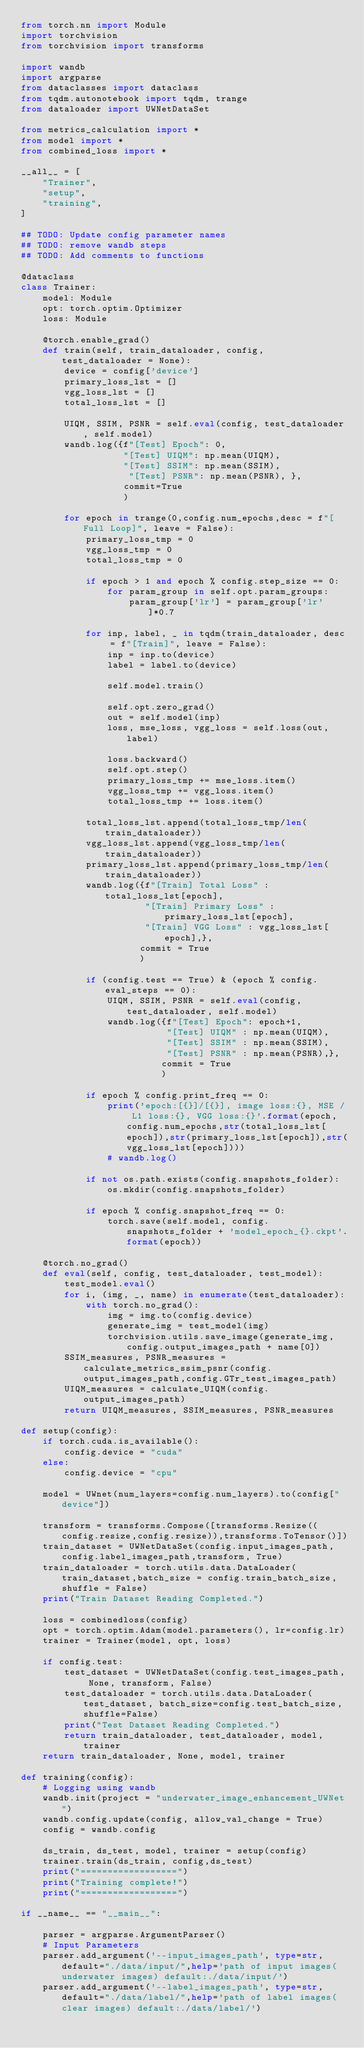<code> <loc_0><loc_0><loc_500><loc_500><_Python_>from torch.nn import Module
import torchvision
from torchvision import transforms

import wandb
import argparse
from dataclasses import dataclass
from tqdm.autonotebook import tqdm, trange
from dataloader import UWNetDataSet

from metrics_calculation import *
from model import *
from combined_loss import *

__all__ = [
    "Trainer",
    "setup",
    "training",
]

## TODO: Update config parameter names
## TODO: remove wandb steps
## TODO: Add comments to functions

@dataclass
class Trainer:
    model: Module
    opt: torch.optim.Optimizer
    loss: Module

    @torch.enable_grad()
    def train(self, train_dataloader, config, test_dataloader = None):
        device = config['device']
        primary_loss_lst = []
        vgg_loss_lst = []
        total_loss_lst = []

        UIQM, SSIM, PSNR = self.eval(config, test_dataloader, self.model)
        wandb.log({f"[Test] Epoch": 0,
                   "[Test] UIQM": np.mean(UIQM),
                   "[Test] SSIM": np.mean(SSIM),
                    "[Test] PSNR": np.mean(PSNR), },
                   commit=True
                   )

        for epoch in trange(0,config.num_epochs,desc = f"[Full Loop]", leave = False):
            primary_loss_tmp = 0
            vgg_loss_tmp = 0
            total_loss_tmp = 0

            if epoch > 1 and epoch % config.step_size == 0:
                for param_group in self.opt.param_groups:
                    param_group['lr'] = param_group['lr']*0.7

            for inp, label, _ in tqdm(train_dataloader, desc = f"[Train]", leave = False):
                inp = inp.to(device)
                label = label.to(device)

                self.model.train()

                self.opt.zero_grad()
                out = self.model(inp)
                loss, mse_loss, vgg_loss = self.loss(out, label)

                loss.backward()
                self.opt.step()
                primary_loss_tmp += mse_loss.item()
                vgg_loss_tmp += vgg_loss.item()
                total_loss_tmp += loss.item()

            total_loss_lst.append(total_loss_tmp/len(train_dataloader))
            vgg_loss_lst.append(vgg_loss_tmp/len(train_dataloader))
            primary_loss_lst.append(primary_loss_tmp/len(train_dataloader))
            wandb.log({f"[Train] Total Loss" : total_loss_lst[epoch],
                       "[Train] Primary Loss" : primary_loss_lst[epoch],
                       "[Train] VGG Loss" : vgg_loss_lst[epoch],},
                      commit = True
                      )

            if (config.test == True) & (epoch % config.eval_steps == 0):
                UIQM, SSIM, PSNR = self.eval(config, test_dataloader, self.model)
                wandb.log({f"[Test] Epoch": epoch+1,
                           "[Test] UIQM" : np.mean(UIQM),
                           "[Test] SSIM" : np.mean(SSIM),
                           "[Test] PSNR" : np.mean(PSNR),},
                          commit = True
                          )

            if epoch % config.print_freq == 0:
                print('epoch:[{}]/[{}], image loss:{}, MSE / L1 loss:{}, VGG loss:{}'.format(epoch,config.num_epochs,str(total_loss_lst[epoch]),str(primary_loss_lst[epoch]),str(vgg_loss_lst[epoch])))
                # wandb.log()

            if not os.path.exists(config.snapshots_folder):
                os.mkdir(config.snapshots_folder)

            if epoch % config.snapshot_freq == 0:
                torch.save(self.model, config.snapshots_folder + 'model_epoch_{}.ckpt'.format(epoch))

    @torch.no_grad()
    def eval(self, config, test_dataloader, test_model):
        test_model.eval()
        for i, (img, _, name) in enumerate(test_dataloader):
            with torch.no_grad():
                img = img.to(config.device)
                generate_img = test_model(img)
                torchvision.utils.save_image(generate_img, config.output_images_path + name[0])
        SSIM_measures, PSNR_measures = calculate_metrics_ssim_psnr(config.output_images_path,config.GTr_test_images_path)
        UIQM_measures = calculate_UIQM(config.output_images_path)
        return UIQM_measures, SSIM_measures, PSNR_measures

def setup(config):
    if torch.cuda.is_available():
        config.device = "cuda"
    else:
        config.device = "cpu"

    model = UWnet(num_layers=config.num_layers).to(config["device"])

    transform = transforms.Compose([transforms.Resize((config.resize,config.resize)),transforms.ToTensor()])
    train_dataset = UWNetDataSet(config.input_images_path,config.label_images_path,transform, True)
    train_dataloader = torch.utils.data.DataLoader(train_dataset,batch_size = config.train_batch_size,shuffle = False)
    print("Train Dataset Reading Completed.")

    loss = combinedloss(config)
    opt = torch.optim.Adam(model.parameters(), lr=config.lr)
    trainer = Trainer(model, opt, loss)

    if config.test:
        test_dataset = UWNetDataSet(config.test_images_path, None, transform, False)
        test_dataloader = torch.utils.data.DataLoader(test_dataset, batch_size=config.test_batch_size, shuffle=False)
        print("Test Dataset Reading Completed.")
        return train_dataloader, test_dataloader, model, trainer
    return train_dataloader, None, model, trainer

def training(config):
    # Logging using wandb
    wandb.init(project = "underwater_image_enhancement_UWNet")
    wandb.config.update(config, allow_val_change = True)
    config = wandb.config

    ds_train, ds_test, model, trainer = setup(config)
    trainer.train(ds_train, config,ds_test)
    print("==================")
    print("Training complete!")
    print("==================")

if __name__ == "__main__":

    parser = argparse.ArgumentParser()
    # Input Parameters
    parser.add_argument('--input_images_path', type=str, default="./data/input/",help='path of input images(underwater images) default:./data/input/')
    parser.add_argument('--label_images_path', type=str, default="./data/label/",help='path of label images(clear images) default:./data/label/')</code> 